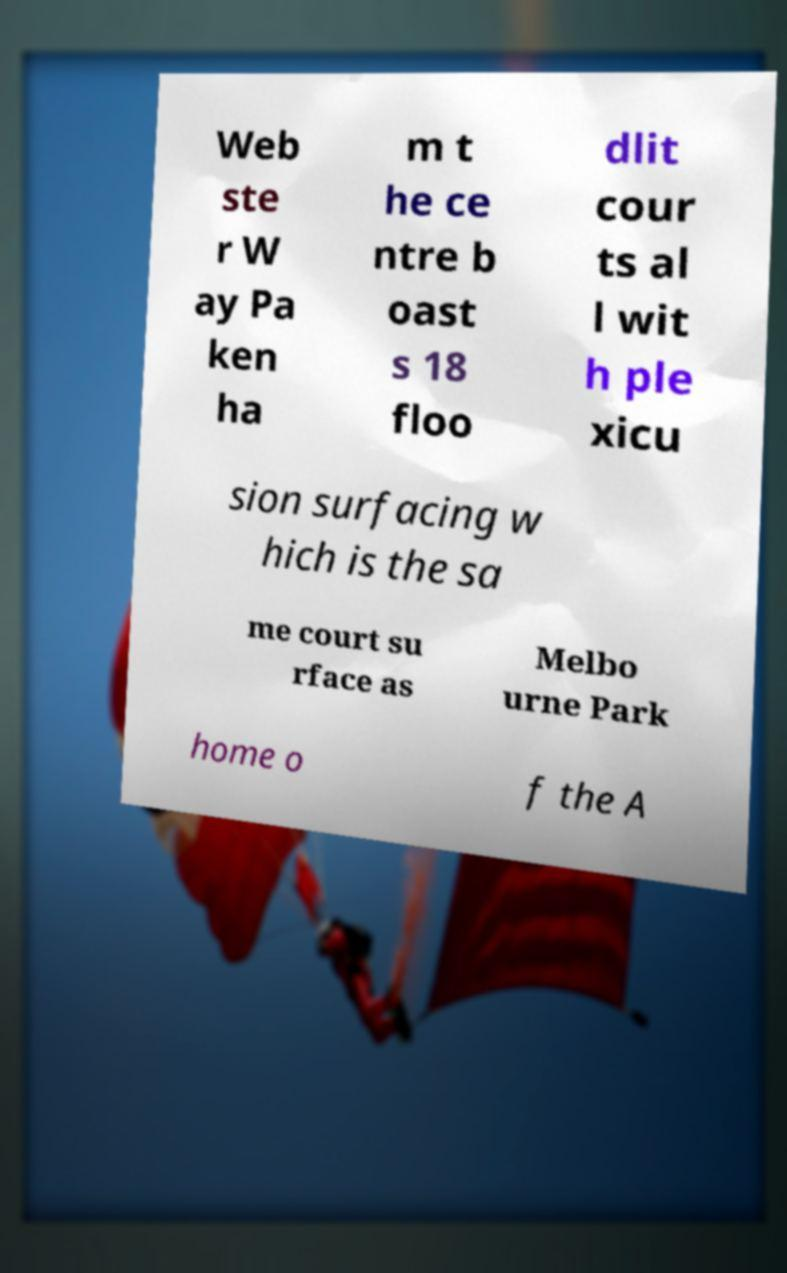Can you read and provide the text displayed in the image?This photo seems to have some interesting text. Can you extract and type it out for me? Web ste r W ay Pa ken ha m t he ce ntre b oast s 18 floo dlit cour ts al l wit h ple xicu sion surfacing w hich is the sa me court su rface as Melbo urne Park home o f the A 